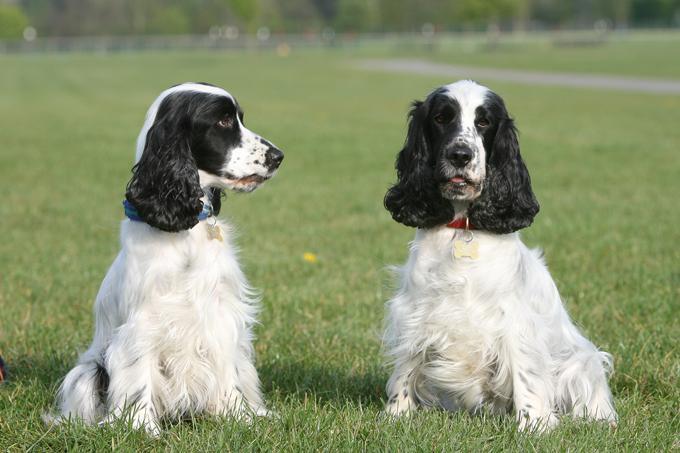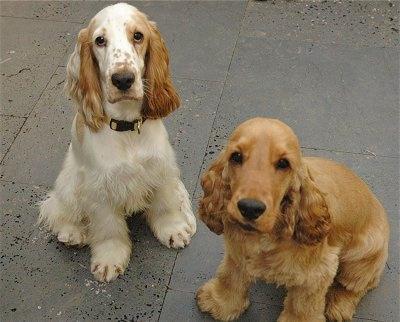The first image is the image on the left, the second image is the image on the right. Given the left and right images, does the statement "At least one half of the dogs have their mouths open." hold true? Answer yes or no. No. The first image is the image on the left, the second image is the image on the right. Assess this claim about the two images: "There are at most four dogs.". Correct or not? Answer yes or no. Yes. 